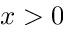Convert formula to latex. <formula><loc_0><loc_0><loc_500><loc_500>x > 0</formula> 